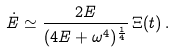Convert formula to latex. <formula><loc_0><loc_0><loc_500><loc_500>\dot { E } \simeq \frac { 2 E } { ( 4 E + \omega ^ { 4 } ) ^ { \frac { 1 } { 4 } } } \, \Xi ( t ) \, .</formula> 